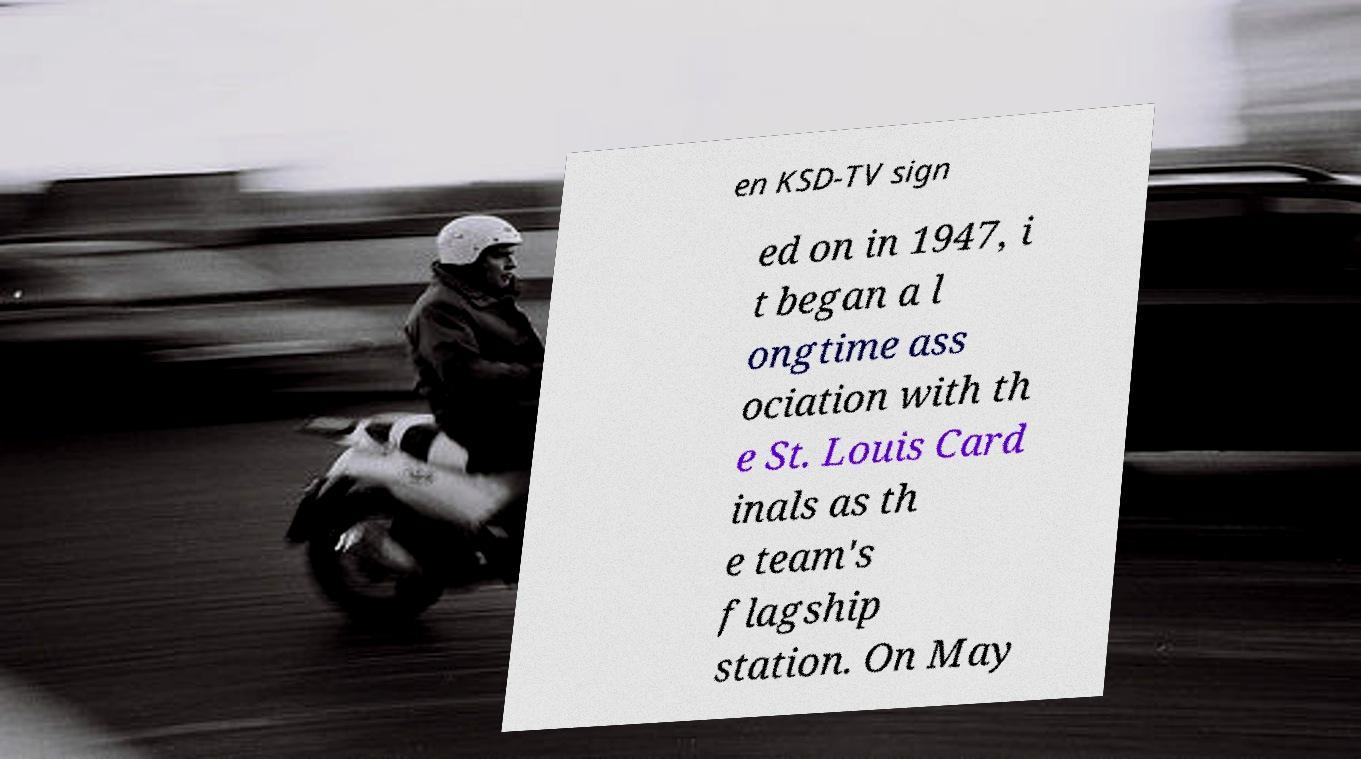Can you accurately transcribe the text from the provided image for me? en KSD-TV sign ed on in 1947, i t began a l ongtime ass ociation with th e St. Louis Card inals as th e team's flagship station. On May 